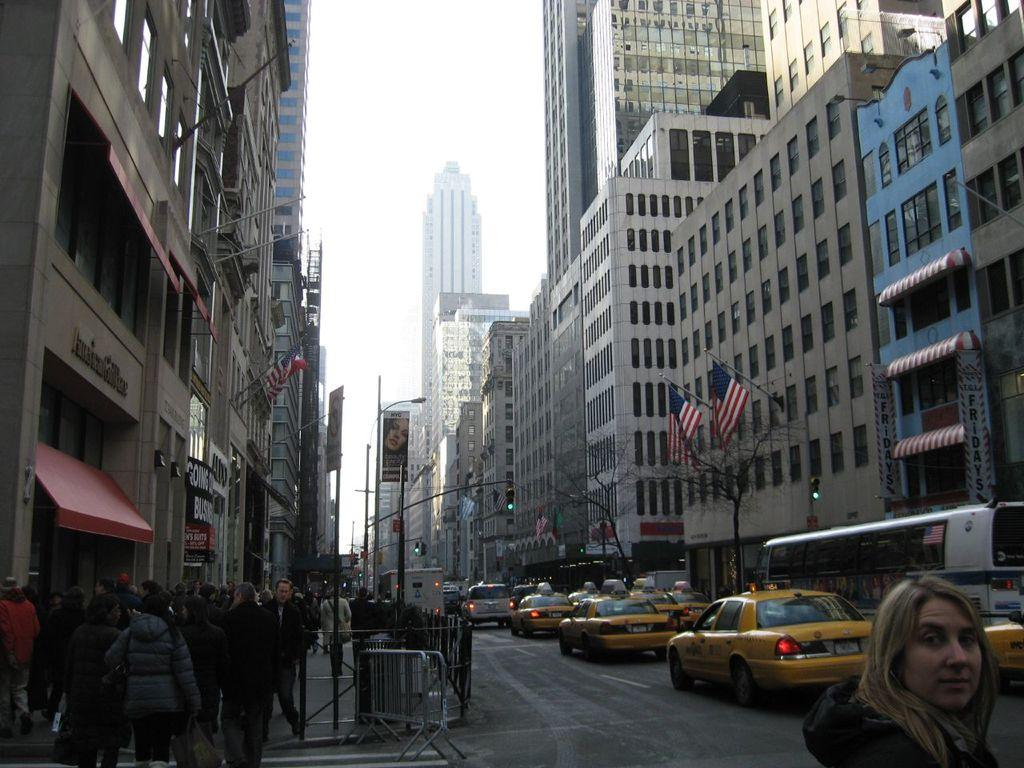<image>
Create a compact narrative representing the image presented. A street with lots of buildings and taxis and a sign saying GOING. 